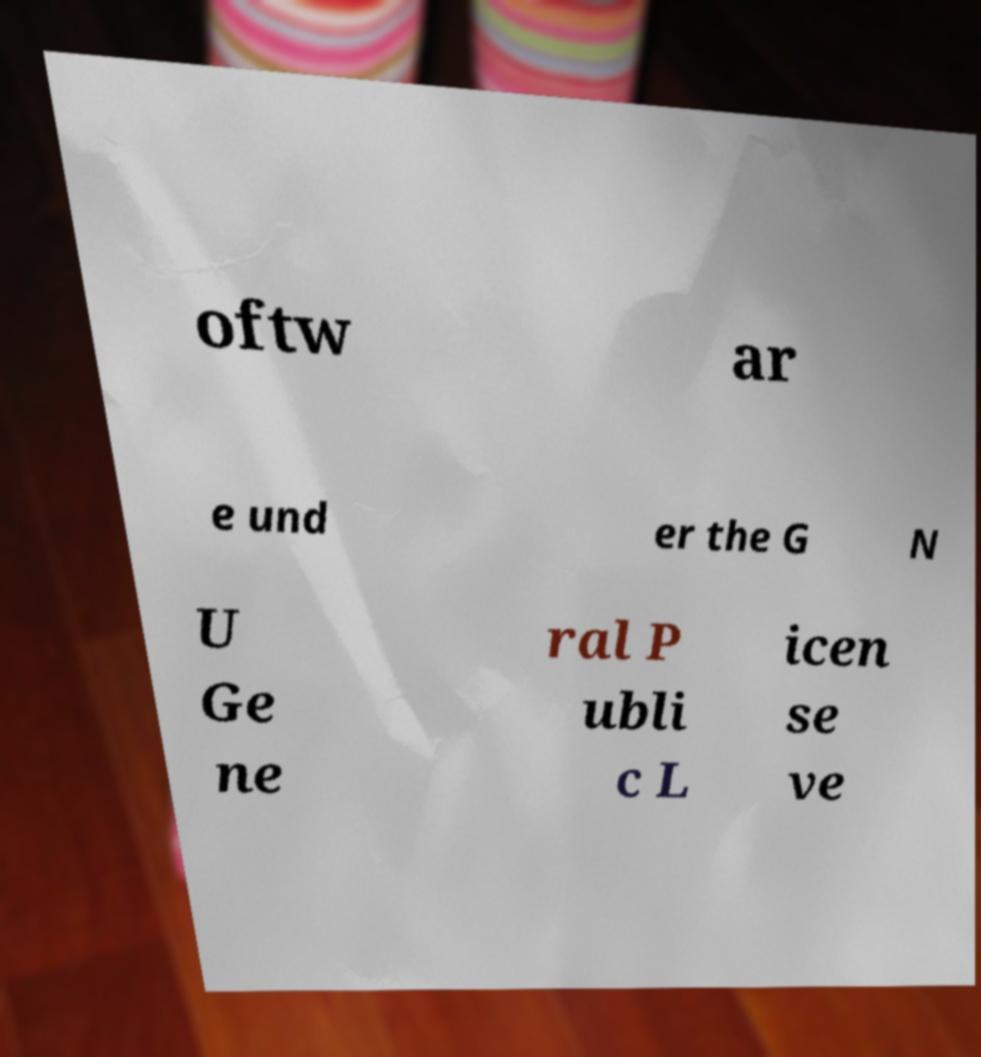Can you accurately transcribe the text from the provided image for me? oftw ar e und er the G N U Ge ne ral P ubli c L icen se ve 